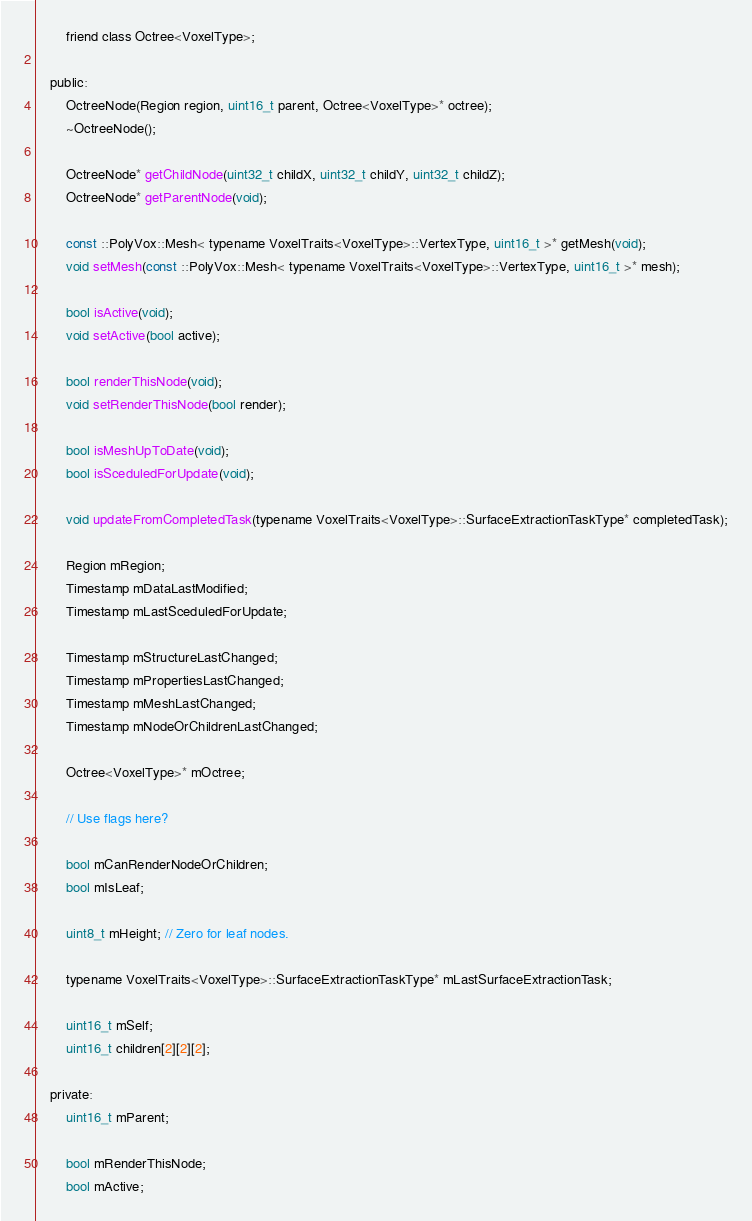Convert code to text. <code><loc_0><loc_0><loc_500><loc_500><_C_>		friend class Octree<VoxelType>;

	public:	
		OctreeNode(Region region, uint16_t parent, Octree<VoxelType>* octree);
		~OctreeNode();

		OctreeNode* getChildNode(uint32_t childX, uint32_t childY, uint32_t childZ);
		OctreeNode* getParentNode(void);

		const ::PolyVox::Mesh< typename VoxelTraits<VoxelType>::VertexType, uint16_t >* getMesh(void);
		void setMesh(const ::PolyVox::Mesh< typename VoxelTraits<VoxelType>::VertexType, uint16_t >* mesh);

		bool isActive(void);
		void setActive(bool active);

		bool renderThisNode(void);
		void setRenderThisNode(bool render);

		bool isMeshUpToDate(void);
		bool isSceduledForUpdate(void);

		void updateFromCompletedTask(typename VoxelTraits<VoxelType>::SurfaceExtractionTaskType* completedTask);

		Region mRegion;
		Timestamp mDataLastModified;
		Timestamp mLastSceduledForUpdate;

		Timestamp mStructureLastChanged;
		Timestamp mPropertiesLastChanged;
		Timestamp mMeshLastChanged;
		Timestamp mNodeOrChildrenLastChanged;

		Octree<VoxelType>* mOctree;

		// Use flags here?
		
		bool mCanRenderNodeOrChildren;
		bool mIsLeaf;

		uint8_t mHeight; // Zero for leaf nodes.

		typename VoxelTraits<VoxelType>::SurfaceExtractionTaskType* mLastSurfaceExtractionTask;

		uint16_t mSelf;
		uint16_t children[2][2][2];

	private:
		uint16_t mParent;		

		bool mRenderThisNode;
		bool mActive;
</code> 